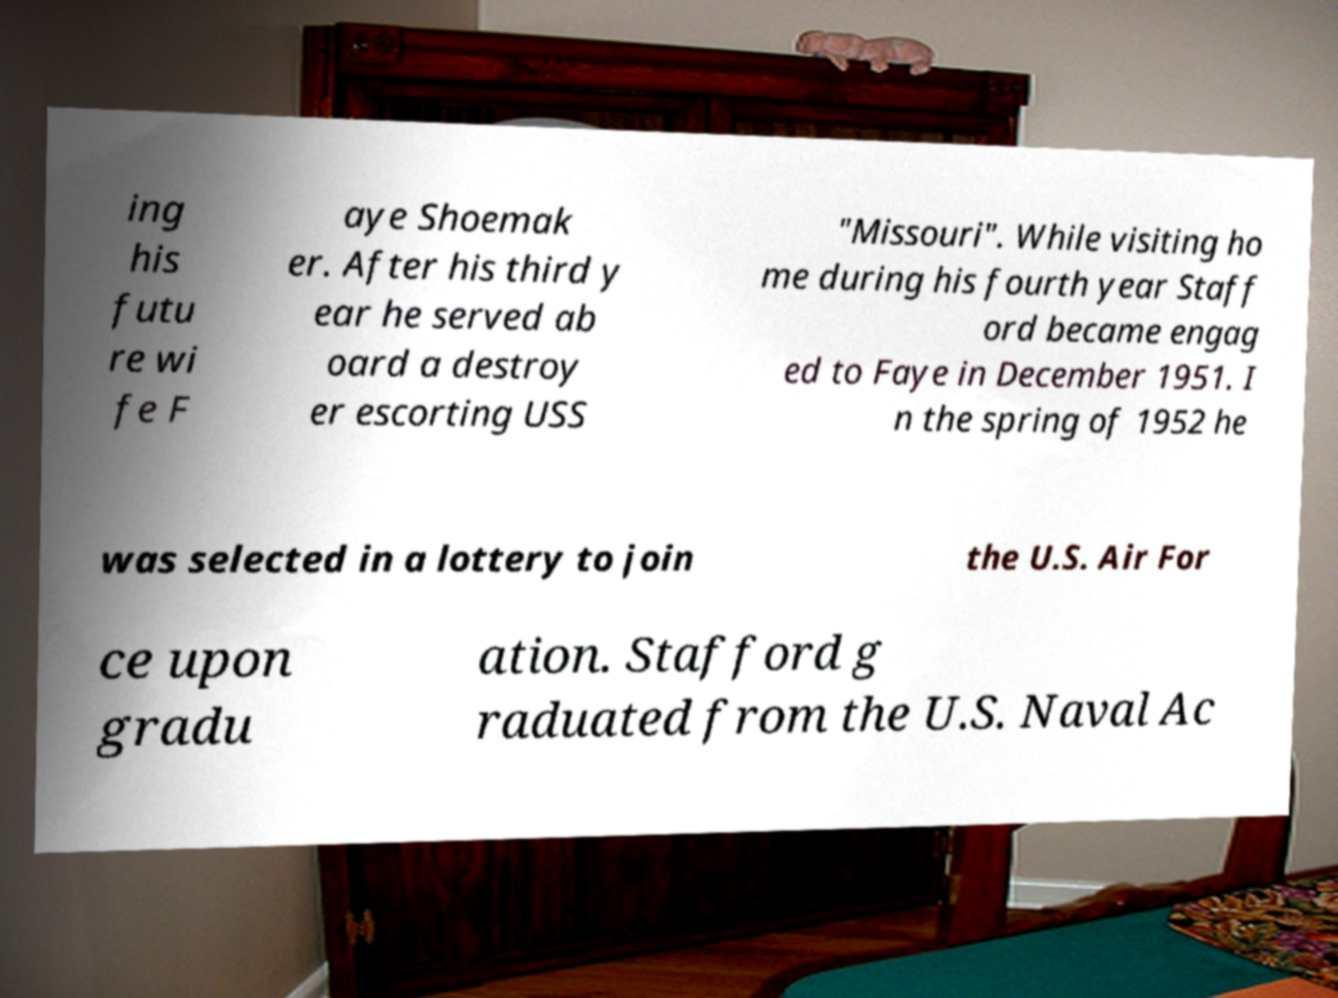Please identify and transcribe the text found in this image. ing his futu re wi fe F aye Shoemak er. After his third y ear he served ab oard a destroy er escorting USS "Missouri". While visiting ho me during his fourth year Staff ord became engag ed to Faye in December 1951. I n the spring of 1952 he was selected in a lottery to join the U.S. Air For ce upon gradu ation. Stafford g raduated from the U.S. Naval Ac 